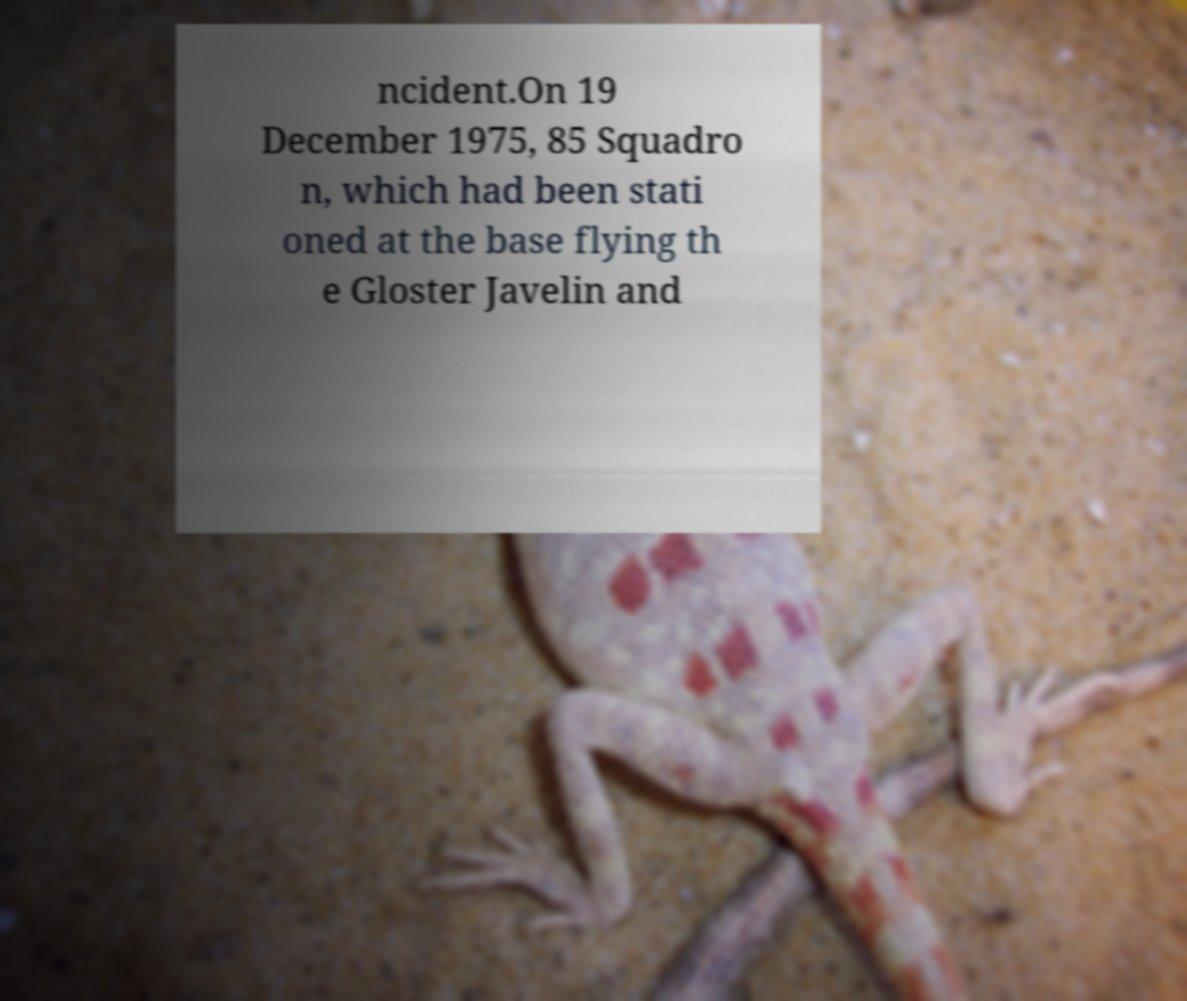Please read and relay the text visible in this image. What does it say? ncident.On 19 December 1975, 85 Squadro n, which had been stati oned at the base flying th e Gloster Javelin and 